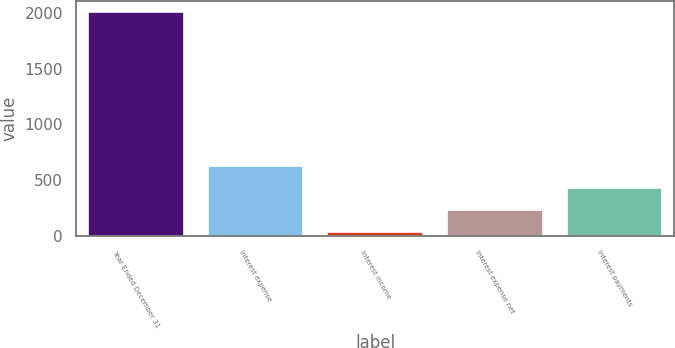Convert chart. <chart><loc_0><loc_0><loc_500><loc_500><bar_chart><fcel>Year Ended December 31<fcel>Interest expense<fcel>Interest income<fcel>Interest expense net<fcel>Interest payments<nl><fcel>2005<fcel>626.7<fcel>36<fcel>232.9<fcel>429.8<nl></chart> 